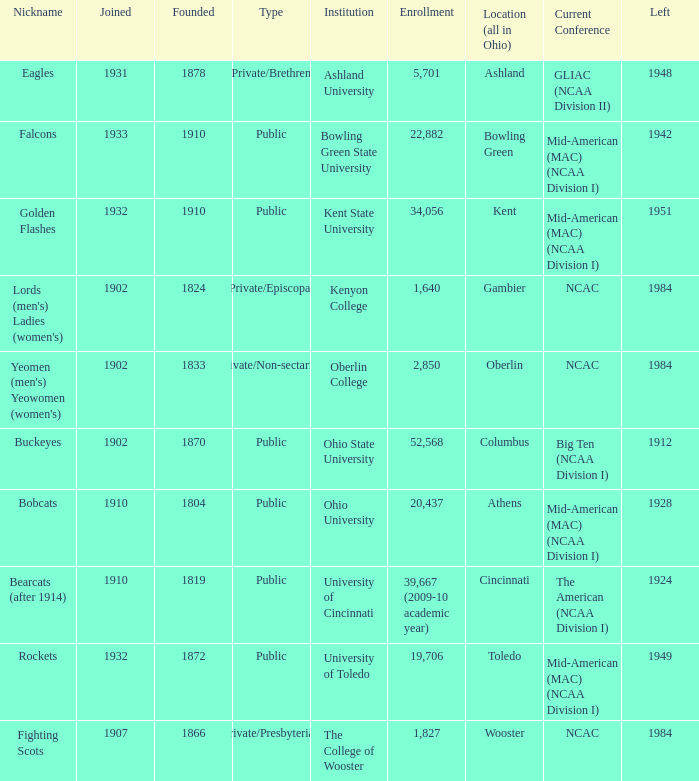What is the enrollment for Ashland University? 5701.0. 